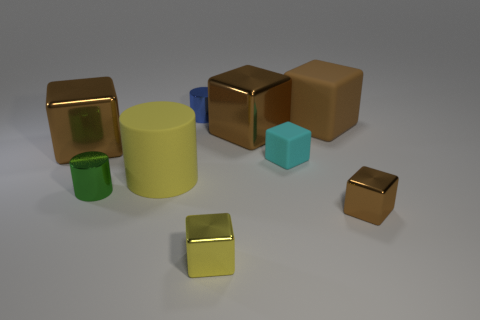Which objects in the image seem to share the same material, and how can you tell? The two golden cubes and the two small yellow cubes share a similar shiny metallic material, which can be deduced from their reflective surfaces and the way they interact with the light in the environment. 